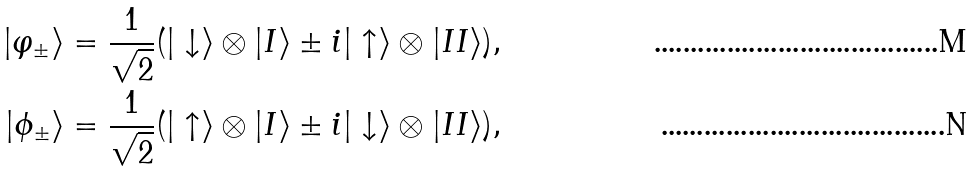<formula> <loc_0><loc_0><loc_500><loc_500>| \varphi _ { \pm } \rangle & = \frac { 1 } { \sqrt { 2 } } ( | \downarrow \rangle \otimes | I \rangle \pm i | \uparrow \rangle \otimes | I I \rangle ) , \\ | \phi _ { \pm } \rangle & = \frac { 1 } { \sqrt { 2 } } ( | \uparrow \rangle \otimes | I \rangle \pm i | \downarrow \rangle \otimes | I I \rangle ) ,</formula> 